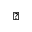Convert formula to latex. <formula><loc_0><loc_0><loc_500><loc_500>\blacktriangledown</formula> 